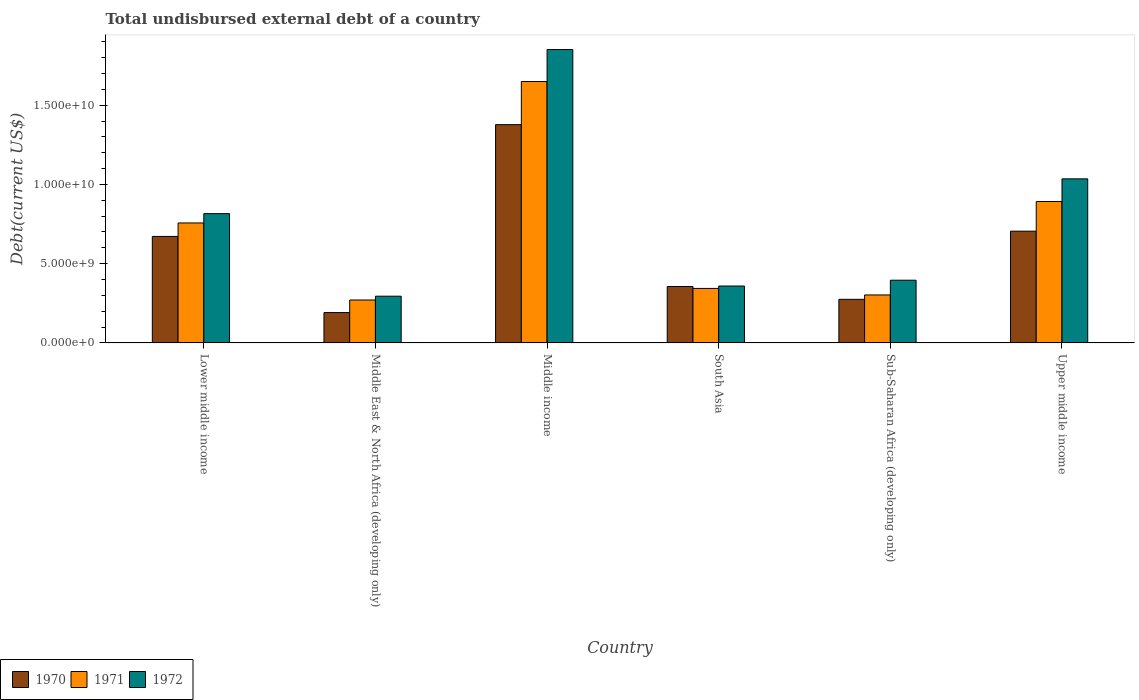How many different coloured bars are there?
Provide a short and direct response. 3. How many groups of bars are there?
Offer a very short reply. 6. Are the number of bars per tick equal to the number of legend labels?
Your answer should be very brief. Yes. Are the number of bars on each tick of the X-axis equal?
Your response must be concise. Yes. What is the label of the 2nd group of bars from the left?
Ensure brevity in your answer.  Middle East & North Africa (developing only). In how many cases, is the number of bars for a given country not equal to the number of legend labels?
Provide a short and direct response. 0. What is the total undisbursed external debt in 1972 in Middle East & North Africa (developing only)?
Offer a very short reply. 2.95e+09. Across all countries, what is the maximum total undisbursed external debt in 1970?
Give a very brief answer. 1.38e+1. Across all countries, what is the minimum total undisbursed external debt in 1972?
Provide a short and direct response. 2.95e+09. In which country was the total undisbursed external debt in 1970 minimum?
Make the answer very short. Middle East & North Africa (developing only). What is the total total undisbursed external debt in 1972 in the graph?
Offer a very short reply. 4.75e+1. What is the difference between the total undisbursed external debt in 1971 in Lower middle income and that in Middle East & North Africa (developing only)?
Your answer should be very brief. 4.86e+09. What is the difference between the total undisbursed external debt in 1970 in South Asia and the total undisbursed external debt in 1972 in Middle East & North Africa (developing only)?
Your answer should be very brief. 6.12e+08. What is the average total undisbursed external debt in 1971 per country?
Provide a short and direct response. 7.03e+09. What is the difference between the total undisbursed external debt of/in 1972 and total undisbursed external debt of/in 1970 in Middle income?
Offer a terse response. 4.74e+09. What is the ratio of the total undisbursed external debt in 1972 in South Asia to that in Sub-Saharan Africa (developing only)?
Your answer should be compact. 0.91. Is the difference between the total undisbursed external debt in 1972 in Middle East & North Africa (developing only) and Upper middle income greater than the difference between the total undisbursed external debt in 1970 in Middle East & North Africa (developing only) and Upper middle income?
Your answer should be very brief. No. What is the difference between the highest and the second highest total undisbursed external debt in 1971?
Ensure brevity in your answer.  1.35e+09. What is the difference between the highest and the lowest total undisbursed external debt in 1970?
Offer a very short reply. 1.19e+1. In how many countries, is the total undisbursed external debt in 1970 greater than the average total undisbursed external debt in 1970 taken over all countries?
Your answer should be compact. 3. Is it the case that in every country, the sum of the total undisbursed external debt in 1972 and total undisbursed external debt in 1971 is greater than the total undisbursed external debt in 1970?
Your response must be concise. Yes. How many bars are there?
Your response must be concise. 18. Are all the bars in the graph horizontal?
Offer a very short reply. No. Where does the legend appear in the graph?
Your answer should be very brief. Bottom left. What is the title of the graph?
Make the answer very short. Total undisbursed external debt of a country. Does "2012" appear as one of the legend labels in the graph?
Your response must be concise. No. What is the label or title of the Y-axis?
Your response must be concise. Debt(current US$). What is the Debt(current US$) in 1970 in Lower middle income?
Your answer should be compact. 6.72e+09. What is the Debt(current US$) in 1971 in Lower middle income?
Offer a very short reply. 7.57e+09. What is the Debt(current US$) in 1972 in Lower middle income?
Provide a short and direct response. 8.16e+09. What is the Debt(current US$) of 1970 in Middle East & North Africa (developing only)?
Your answer should be compact. 1.92e+09. What is the Debt(current US$) in 1971 in Middle East & North Africa (developing only)?
Your answer should be compact. 2.71e+09. What is the Debt(current US$) of 1972 in Middle East & North Africa (developing only)?
Offer a very short reply. 2.95e+09. What is the Debt(current US$) in 1970 in Middle income?
Your response must be concise. 1.38e+1. What is the Debt(current US$) of 1971 in Middle income?
Your answer should be compact. 1.65e+1. What is the Debt(current US$) of 1972 in Middle income?
Your answer should be compact. 1.85e+1. What is the Debt(current US$) of 1970 in South Asia?
Give a very brief answer. 3.56e+09. What is the Debt(current US$) of 1971 in South Asia?
Your response must be concise. 3.44e+09. What is the Debt(current US$) in 1972 in South Asia?
Ensure brevity in your answer.  3.59e+09. What is the Debt(current US$) in 1970 in Sub-Saharan Africa (developing only)?
Your response must be concise. 2.75e+09. What is the Debt(current US$) of 1971 in Sub-Saharan Africa (developing only)?
Offer a terse response. 3.03e+09. What is the Debt(current US$) of 1972 in Sub-Saharan Africa (developing only)?
Keep it short and to the point. 3.96e+09. What is the Debt(current US$) of 1970 in Upper middle income?
Offer a terse response. 7.05e+09. What is the Debt(current US$) in 1971 in Upper middle income?
Your answer should be compact. 8.92e+09. What is the Debt(current US$) of 1972 in Upper middle income?
Give a very brief answer. 1.04e+1. Across all countries, what is the maximum Debt(current US$) in 1970?
Your answer should be compact. 1.38e+1. Across all countries, what is the maximum Debt(current US$) of 1971?
Your answer should be compact. 1.65e+1. Across all countries, what is the maximum Debt(current US$) of 1972?
Ensure brevity in your answer.  1.85e+1. Across all countries, what is the minimum Debt(current US$) of 1970?
Offer a terse response. 1.92e+09. Across all countries, what is the minimum Debt(current US$) in 1971?
Offer a very short reply. 2.71e+09. Across all countries, what is the minimum Debt(current US$) of 1972?
Your response must be concise. 2.95e+09. What is the total Debt(current US$) of 1970 in the graph?
Your answer should be very brief. 3.58e+1. What is the total Debt(current US$) in 1971 in the graph?
Offer a terse response. 4.22e+1. What is the total Debt(current US$) of 1972 in the graph?
Provide a short and direct response. 4.75e+1. What is the difference between the Debt(current US$) of 1970 in Lower middle income and that in Middle East & North Africa (developing only)?
Give a very brief answer. 4.80e+09. What is the difference between the Debt(current US$) in 1971 in Lower middle income and that in Middle East & North Africa (developing only)?
Give a very brief answer. 4.86e+09. What is the difference between the Debt(current US$) of 1972 in Lower middle income and that in Middle East & North Africa (developing only)?
Provide a short and direct response. 5.21e+09. What is the difference between the Debt(current US$) in 1970 in Lower middle income and that in Middle income?
Keep it short and to the point. -7.05e+09. What is the difference between the Debt(current US$) of 1971 in Lower middle income and that in Middle income?
Your answer should be compact. -8.92e+09. What is the difference between the Debt(current US$) of 1972 in Lower middle income and that in Middle income?
Offer a very short reply. -1.04e+1. What is the difference between the Debt(current US$) of 1970 in Lower middle income and that in South Asia?
Your answer should be very brief. 3.16e+09. What is the difference between the Debt(current US$) of 1971 in Lower middle income and that in South Asia?
Your response must be concise. 4.13e+09. What is the difference between the Debt(current US$) of 1972 in Lower middle income and that in South Asia?
Your response must be concise. 4.57e+09. What is the difference between the Debt(current US$) in 1970 in Lower middle income and that in Sub-Saharan Africa (developing only)?
Provide a short and direct response. 3.97e+09. What is the difference between the Debt(current US$) in 1971 in Lower middle income and that in Sub-Saharan Africa (developing only)?
Offer a very short reply. 4.54e+09. What is the difference between the Debt(current US$) in 1972 in Lower middle income and that in Sub-Saharan Africa (developing only)?
Make the answer very short. 4.20e+09. What is the difference between the Debt(current US$) in 1970 in Lower middle income and that in Upper middle income?
Ensure brevity in your answer.  -3.32e+08. What is the difference between the Debt(current US$) of 1971 in Lower middle income and that in Upper middle income?
Keep it short and to the point. -1.35e+09. What is the difference between the Debt(current US$) of 1972 in Lower middle income and that in Upper middle income?
Make the answer very short. -2.20e+09. What is the difference between the Debt(current US$) of 1970 in Middle East & North Africa (developing only) and that in Middle income?
Make the answer very short. -1.19e+1. What is the difference between the Debt(current US$) in 1971 in Middle East & North Africa (developing only) and that in Middle income?
Offer a terse response. -1.38e+1. What is the difference between the Debt(current US$) in 1972 in Middle East & North Africa (developing only) and that in Middle income?
Keep it short and to the point. -1.56e+1. What is the difference between the Debt(current US$) in 1970 in Middle East & North Africa (developing only) and that in South Asia?
Make the answer very short. -1.64e+09. What is the difference between the Debt(current US$) in 1971 in Middle East & North Africa (developing only) and that in South Asia?
Your answer should be compact. -7.30e+08. What is the difference between the Debt(current US$) in 1972 in Middle East & North Africa (developing only) and that in South Asia?
Keep it short and to the point. -6.42e+08. What is the difference between the Debt(current US$) of 1970 in Middle East & North Africa (developing only) and that in Sub-Saharan Africa (developing only)?
Make the answer very short. -8.36e+08. What is the difference between the Debt(current US$) of 1971 in Middle East & North Africa (developing only) and that in Sub-Saharan Africa (developing only)?
Your answer should be compact. -3.18e+08. What is the difference between the Debt(current US$) of 1972 in Middle East & North Africa (developing only) and that in Sub-Saharan Africa (developing only)?
Your answer should be compact. -1.01e+09. What is the difference between the Debt(current US$) of 1970 in Middle East & North Africa (developing only) and that in Upper middle income?
Keep it short and to the point. -5.14e+09. What is the difference between the Debt(current US$) of 1971 in Middle East & North Africa (developing only) and that in Upper middle income?
Your answer should be very brief. -6.21e+09. What is the difference between the Debt(current US$) in 1972 in Middle East & North Africa (developing only) and that in Upper middle income?
Offer a very short reply. -7.40e+09. What is the difference between the Debt(current US$) of 1970 in Middle income and that in South Asia?
Make the answer very short. 1.02e+1. What is the difference between the Debt(current US$) in 1971 in Middle income and that in South Asia?
Give a very brief answer. 1.31e+1. What is the difference between the Debt(current US$) in 1972 in Middle income and that in South Asia?
Offer a terse response. 1.49e+1. What is the difference between the Debt(current US$) in 1970 in Middle income and that in Sub-Saharan Africa (developing only)?
Offer a terse response. 1.10e+1. What is the difference between the Debt(current US$) of 1971 in Middle income and that in Sub-Saharan Africa (developing only)?
Give a very brief answer. 1.35e+1. What is the difference between the Debt(current US$) of 1972 in Middle income and that in Sub-Saharan Africa (developing only)?
Make the answer very short. 1.46e+1. What is the difference between the Debt(current US$) in 1970 in Middle income and that in Upper middle income?
Offer a very short reply. 6.72e+09. What is the difference between the Debt(current US$) in 1971 in Middle income and that in Upper middle income?
Provide a short and direct response. 7.57e+09. What is the difference between the Debt(current US$) of 1972 in Middle income and that in Upper middle income?
Give a very brief answer. 8.16e+09. What is the difference between the Debt(current US$) in 1970 in South Asia and that in Sub-Saharan Africa (developing only)?
Your response must be concise. 8.09e+08. What is the difference between the Debt(current US$) in 1971 in South Asia and that in Sub-Saharan Africa (developing only)?
Make the answer very short. 4.11e+08. What is the difference between the Debt(current US$) of 1972 in South Asia and that in Sub-Saharan Africa (developing only)?
Ensure brevity in your answer.  -3.67e+08. What is the difference between the Debt(current US$) of 1970 in South Asia and that in Upper middle income?
Ensure brevity in your answer.  -3.49e+09. What is the difference between the Debt(current US$) of 1971 in South Asia and that in Upper middle income?
Keep it short and to the point. -5.48e+09. What is the difference between the Debt(current US$) in 1972 in South Asia and that in Upper middle income?
Offer a very short reply. -6.76e+09. What is the difference between the Debt(current US$) in 1970 in Sub-Saharan Africa (developing only) and that in Upper middle income?
Your answer should be compact. -4.30e+09. What is the difference between the Debt(current US$) of 1971 in Sub-Saharan Africa (developing only) and that in Upper middle income?
Your response must be concise. -5.89e+09. What is the difference between the Debt(current US$) in 1972 in Sub-Saharan Africa (developing only) and that in Upper middle income?
Provide a succinct answer. -6.39e+09. What is the difference between the Debt(current US$) in 1970 in Lower middle income and the Debt(current US$) in 1971 in Middle East & North Africa (developing only)?
Ensure brevity in your answer.  4.01e+09. What is the difference between the Debt(current US$) of 1970 in Lower middle income and the Debt(current US$) of 1972 in Middle East & North Africa (developing only)?
Keep it short and to the point. 3.77e+09. What is the difference between the Debt(current US$) in 1971 in Lower middle income and the Debt(current US$) in 1972 in Middle East & North Africa (developing only)?
Your response must be concise. 4.62e+09. What is the difference between the Debt(current US$) of 1970 in Lower middle income and the Debt(current US$) of 1971 in Middle income?
Provide a succinct answer. -9.77e+09. What is the difference between the Debt(current US$) of 1970 in Lower middle income and the Debt(current US$) of 1972 in Middle income?
Ensure brevity in your answer.  -1.18e+1. What is the difference between the Debt(current US$) in 1971 in Lower middle income and the Debt(current US$) in 1972 in Middle income?
Your response must be concise. -1.09e+1. What is the difference between the Debt(current US$) in 1970 in Lower middle income and the Debt(current US$) in 1971 in South Asia?
Ensure brevity in your answer.  3.28e+09. What is the difference between the Debt(current US$) in 1970 in Lower middle income and the Debt(current US$) in 1972 in South Asia?
Your answer should be very brief. 3.13e+09. What is the difference between the Debt(current US$) of 1971 in Lower middle income and the Debt(current US$) of 1972 in South Asia?
Provide a short and direct response. 3.98e+09. What is the difference between the Debt(current US$) in 1970 in Lower middle income and the Debt(current US$) in 1971 in Sub-Saharan Africa (developing only)?
Your answer should be very brief. 3.69e+09. What is the difference between the Debt(current US$) in 1970 in Lower middle income and the Debt(current US$) in 1972 in Sub-Saharan Africa (developing only)?
Ensure brevity in your answer.  2.76e+09. What is the difference between the Debt(current US$) of 1971 in Lower middle income and the Debt(current US$) of 1972 in Sub-Saharan Africa (developing only)?
Provide a short and direct response. 3.61e+09. What is the difference between the Debt(current US$) of 1970 in Lower middle income and the Debt(current US$) of 1971 in Upper middle income?
Offer a terse response. -2.20e+09. What is the difference between the Debt(current US$) in 1970 in Lower middle income and the Debt(current US$) in 1972 in Upper middle income?
Your answer should be very brief. -3.63e+09. What is the difference between the Debt(current US$) in 1971 in Lower middle income and the Debt(current US$) in 1972 in Upper middle income?
Provide a short and direct response. -2.78e+09. What is the difference between the Debt(current US$) in 1970 in Middle East & North Africa (developing only) and the Debt(current US$) in 1971 in Middle income?
Keep it short and to the point. -1.46e+1. What is the difference between the Debt(current US$) in 1970 in Middle East & North Africa (developing only) and the Debt(current US$) in 1972 in Middle income?
Ensure brevity in your answer.  -1.66e+1. What is the difference between the Debt(current US$) in 1971 in Middle East & North Africa (developing only) and the Debt(current US$) in 1972 in Middle income?
Provide a succinct answer. -1.58e+1. What is the difference between the Debt(current US$) of 1970 in Middle East & North Africa (developing only) and the Debt(current US$) of 1971 in South Asia?
Provide a succinct answer. -1.52e+09. What is the difference between the Debt(current US$) in 1970 in Middle East & North Africa (developing only) and the Debt(current US$) in 1972 in South Asia?
Your response must be concise. -1.67e+09. What is the difference between the Debt(current US$) of 1971 in Middle East & North Africa (developing only) and the Debt(current US$) of 1972 in South Asia?
Offer a terse response. -8.81e+08. What is the difference between the Debt(current US$) of 1970 in Middle East & North Africa (developing only) and the Debt(current US$) of 1971 in Sub-Saharan Africa (developing only)?
Make the answer very short. -1.11e+09. What is the difference between the Debt(current US$) of 1970 in Middle East & North Africa (developing only) and the Debt(current US$) of 1972 in Sub-Saharan Africa (developing only)?
Ensure brevity in your answer.  -2.04e+09. What is the difference between the Debt(current US$) in 1971 in Middle East & North Africa (developing only) and the Debt(current US$) in 1972 in Sub-Saharan Africa (developing only)?
Offer a terse response. -1.25e+09. What is the difference between the Debt(current US$) of 1970 in Middle East & North Africa (developing only) and the Debt(current US$) of 1971 in Upper middle income?
Make the answer very short. -7.01e+09. What is the difference between the Debt(current US$) in 1970 in Middle East & North Africa (developing only) and the Debt(current US$) in 1972 in Upper middle income?
Give a very brief answer. -8.44e+09. What is the difference between the Debt(current US$) of 1971 in Middle East & North Africa (developing only) and the Debt(current US$) of 1972 in Upper middle income?
Your response must be concise. -7.64e+09. What is the difference between the Debt(current US$) of 1970 in Middle income and the Debt(current US$) of 1971 in South Asia?
Your response must be concise. 1.03e+1. What is the difference between the Debt(current US$) of 1970 in Middle income and the Debt(current US$) of 1972 in South Asia?
Your answer should be very brief. 1.02e+1. What is the difference between the Debt(current US$) in 1971 in Middle income and the Debt(current US$) in 1972 in South Asia?
Provide a short and direct response. 1.29e+1. What is the difference between the Debt(current US$) of 1970 in Middle income and the Debt(current US$) of 1971 in Sub-Saharan Africa (developing only)?
Your response must be concise. 1.07e+1. What is the difference between the Debt(current US$) of 1970 in Middle income and the Debt(current US$) of 1972 in Sub-Saharan Africa (developing only)?
Provide a succinct answer. 9.81e+09. What is the difference between the Debt(current US$) in 1971 in Middle income and the Debt(current US$) in 1972 in Sub-Saharan Africa (developing only)?
Your answer should be very brief. 1.25e+1. What is the difference between the Debt(current US$) in 1970 in Middle income and the Debt(current US$) in 1971 in Upper middle income?
Make the answer very short. 4.85e+09. What is the difference between the Debt(current US$) in 1970 in Middle income and the Debt(current US$) in 1972 in Upper middle income?
Your answer should be compact. 3.42e+09. What is the difference between the Debt(current US$) in 1971 in Middle income and the Debt(current US$) in 1972 in Upper middle income?
Your answer should be compact. 6.14e+09. What is the difference between the Debt(current US$) in 1970 in South Asia and the Debt(current US$) in 1971 in Sub-Saharan Africa (developing only)?
Your answer should be compact. 5.33e+08. What is the difference between the Debt(current US$) in 1970 in South Asia and the Debt(current US$) in 1972 in Sub-Saharan Africa (developing only)?
Your response must be concise. -3.97e+08. What is the difference between the Debt(current US$) in 1971 in South Asia and the Debt(current US$) in 1972 in Sub-Saharan Africa (developing only)?
Offer a very short reply. -5.18e+08. What is the difference between the Debt(current US$) in 1970 in South Asia and the Debt(current US$) in 1971 in Upper middle income?
Make the answer very short. -5.36e+09. What is the difference between the Debt(current US$) of 1970 in South Asia and the Debt(current US$) of 1972 in Upper middle income?
Your answer should be compact. -6.79e+09. What is the difference between the Debt(current US$) in 1971 in South Asia and the Debt(current US$) in 1972 in Upper middle income?
Make the answer very short. -6.91e+09. What is the difference between the Debt(current US$) in 1970 in Sub-Saharan Africa (developing only) and the Debt(current US$) in 1971 in Upper middle income?
Ensure brevity in your answer.  -6.17e+09. What is the difference between the Debt(current US$) of 1970 in Sub-Saharan Africa (developing only) and the Debt(current US$) of 1972 in Upper middle income?
Your answer should be compact. -7.60e+09. What is the difference between the Debt(current US$) in 1971 in Sub-Saharan Africa (developing only) and the Debt(current US$) in 1972 in Upper middle income?
Offer a terse response. -7.32e+09. What is the average Debt(current US$) in 1970 per country?
Your answer should be very brief. 5.96e+09. What is the average Debt(current US$) of 1971 per country?
Keep it short and to the point. 7.03e+09. What is the average Debt(current US$) of 1972 per country?
Provide a succinct answer. 7.92e+09. What is the difference between the Debt(current US$) in 1970 and Debt(current US$) in 1971 in Lower middle income?
Your response must be concise. -8.50e+08. What is the difference between the Debt(current US$) of 1970 and Debt(current US$) of 1972 in Lower middle income?
Your answer should be very brief. -1.44e+09. What is the difference between the Debt(current US$) in 1971 and Debt(current US$) in 1972 in Lower middle income?
Your response must be concise. -5.87e+08. What is the difference between the Debt(current US$) in 1970 and Debt(current US$) in 1971 in Middle East & North Africa (developing only)?
Give a very brief answer. -7.94e+08. What is the difference between the Debt(current US$) of 1970 and Debt(current US$) of 1972 in Middle East & North Africa (developing only)?
Ensure brevity in your answer.  -1.03e+09. What is the difference between the Debt(current US$) of 1971 and Debt(current US$) of 1972 in Middle East & North Africa (developing only)?
Give a very brief answer. -2.39e+08. What is the difference between the Debt(current US$) in 1970 and Debt(current US$) in 1971 in Middle income?
Give a very brief answer. -2.72e+09. What is the difference between the Debt(current US$) in 1970 and Debt(current US$) in 1972 in Middle income?
Your response must be concise. -4.74e+09. What is the difference between the Debt(current US$) in 1971 and Debt(current US$) in 1972 in Middle income?
Provide a succinct answer. -2.02e+09. What is the difference between the Debt(current US$) of 1970 and Debt(current US$) of 1971 in South Asia?
Provide a short and direct response. 1.21e+08. What is the difference between the Debt(current US$) in 1970 and Debt(current US$) in 1972 in South Asia?
Your answer should be very brief. -3.02e+07. What is the difference between the Debt(current US$) of 1971 and Debt(current US$) of 1972 in South Asia?
Give a very brief answer. -1.51e+08. What is the difference between the Debt(current US$) in 1970 and Debt(current US$) in 1971 in Sub-Saharan Africa (developing only)?
Your answer should be very brief. -2.76e+08. What is the difference between the Debt(current US$) of 1970 and Debt(current US$) of 1972 in Sub-Saharan Africa (developing only)?
Your response must be concise. -1.21e+09. What is the difference between the Debt(current US$) in 1971 and Debt(current US$) in 1972 in Sub-Saharan Africa (developing only)?
Ensure brevity in your answer.  -9.29e+08. What is the difference between the Debt(current US$) in 1970 and Debt(current US$) in 1971 in Upper middle income?
Offer a terse response. -1.87e+09. What is the difference between the Debt(current US$) in 1970 and Debt(current US$) in 1972 in Upper middle income?
Your response must be concise. -3.30e+09. What is the difference between the Debt(current US$) of 1971 and Debt(current US$) of 1972 in Upper middle income?
Your response must be concise. -1.43e+09. What is the ratio of the Debt(current US$) of 1970 in Lower middle income to that in Middle East & North Africa (developing only)?
Offer a very short reply. 3.51. What is the ratio of the Debt(current US$) of 1971 in Lower middle income to that in Middle East & North Africa (developing only)?
Your answer should be compact. 2.79. What is the ratio of the Debt(current US$) in 1972 in Lower middle income to that in Middle East & North Africa (developing only)?
Offer a terse response. 2.77. What is the ratio of the Debt(current US$) of 1970 in Lower middle income to that in Middle income?
Your response must be concise. 0.49. What is the ratio of the Debt(current US$) in 1971 in Lower middle income to that in Middle income?
Offer a terse response. 0.46. What is the ratio of the Debt(current US$) in 1972 in Lower middle income to that in Middle income?
Provide a succinct answer. 0.44. What is the ratio of the Debt(current US$) of 1970 in Lower middle income to that in South Asia?
Provide a short and direct response. 1.89. What is the ratio of the Debt(current US$) of 1971 in Lower middle income to that in South Asia?
Your answer should be compact. 2.2. What is the ratio of the Debt(current US$) of 1972 in Lower middle income to that in South Asia?
Provide a short and direct response. 2.27. What is the ratio of the Debt(current US$) of 1970 in Lower middle income to that in Sub-Saharan Africa (developing only)?
Your response must be concise. 2.44. What is the ratio of the Debt(current US$) in 1971 in Lower middle income to that in Sub-Saharan Africa (developing only)?
Your answer should be very brief. 2.5. What is the ratio of the Debt(current US$) in 1972 in Lower middle income to that in Sub-Saharan Africa (developing only)?
Give a very brief answer. 2.06. What is the ratio of the Debt(current US$) of 1970 in Lower middle income to that in Upper middle income?
Offer a terse response. 0.95. What is the ratio of the Debt(current US$) of 1971 in Lower middle income to that in Upper middle income?
Ensure brevity in your answer.  0.85. What is the ratio of the Debt(current US$) in 1972 in Lower middle income to that in Upper middle income?
Give a very brief answer. 0.79. What is the ratio of the Debt(current US$) of 1970 in Middle East & North Africa (developing only) to that in Middle income?
Provide a short and direct response. 0.14. What is the ratio of the Debt(current US$) in 1971 in Middle East & North Africa (developing only) to that in Middle income?
Provide a succinct answer. 0.16. What is the ratio of the Debt(current US$) of 1972 in Middle East & North Africa (developing only) to that in Middle income?
Offer a very short reply. 0.16. What is the ratio of the Debt(current US$) in 1970 in Middle East & North Africa (developing only) to that in South Asia?
Provide a succinct answer. 0.54. What is the ratio of the Debt(current US$) in 1971 in Middle East & North Africa (developing only) to that in South Asia?
Make the answer very short. 0.79. What is the ratio of the Debt(current US$) in 1972 in Middle East & North Africa (developing only) to that in South Asia?
Give a very brief answer. 0.82. What is the ratio of the Debt(current US$) in 1970 in Middle East & North Africa (developing only) to that in Sub-Saharan Africa (developing only)?
Offer a terse response. 0.7. What is the ratio of the Debt(current US$) in 1971 in Middle East & North Africa (developing only) to that in Sub-Saharan Africa (developing only)?
Your response must be concise. 0.89. What is the ratio of the Debt(current US$) of 1972 in Middle East & North Africa (developing only) to that in Sub-Saharan Africa (developing only)?
Offer a terse response. 0.75. What is the ratio of the Debt(current US$) of 1970 in Middle East & North Africa (developing only) to that in Upper middle income?
Offer a very short reply. 0.27. What is the ratio of the Debt(current US$) of 1971 in Middle East & North Africa (developing only) to that in Upper middle income?
Your answer should be very brief. 0.3. What is the ratio of the Debt(current US$) in 1972 in Middle East & North Africa (developing only) to that in Upper middle income?
Make the answer very short. 0.28. What is the ratio of the Debt(current US$) of 1970 in Middle income to that in South Asia?
Provide a succinct answer. 3.87. What is the ratio of the Debt(current US$) in 1971 in Middle income to that in South Asia?
Your response must be concise. 4.8. What is the ratio of the Debt(current US$) in 1972 in Middle income to that in South Asia?
Keep it short and to the point. 5.15. What is the ratio of the Debt(current US$) in 1970 in Middle income to that in Sub-Saharan Africa (developing only)?
Offer a very short reply. 5. What is the ratio of the Debt(current US$) of 1971 in Middle income to that in Sub-Saharan Africa (developing only)?
Your answer should be compact. 5.45. What is the ratio of the Debt(current US$) of 1972 in Middle income to that in Sub-Saharan Africa (developing only)?
Your answer should be very brief. 4.68. What is the ratio of the Debt(current US$) of 1970 in Middle income to that in Upper middle income?
Provide a short and direct response. 1.95. What is the ratio of the Debt(current US$) in 1971 in Middle income to that in Upper middle income?
Keep it short and to the point. 1.85. What is the ratio of the Debt(current US$) of 1972 in Middle income to that in Upper middle income?
Make the answer very short. 1.79. What is the ratio of the Debt(current US$) in 1970 in South Asia to that in Sub-Saharan Africa (developing only)?
Give a very brief answer. 1.29. What is the ratio of the Debt(current US$) of 1971 in South Asia to that in Sub-Saharan Africa (developing only)?
Make the answer very short. 1.14. What is the ratio of the Debt(current US$) of 1972 in South Asia to that in Sub-Saharan Africa (developing only)?
Provide a succinct answer. 0.91. What is the ratio of the Debt(current US$) of 1970 in South Asia to that in Upper middle income?
Provide a succinct answer. 0.5. What is the ratio of the Debt(current US$) of 1971 in South Asia to that in Upper middle income?
Offer a terse response. 0.39. What is the ratio of the Debt(current US$) of 1972 in South Asia to that in Upper middle income?
Make the answer very short. 0.35. What is the ratio of the Debt(current US$) of 1970 in Sub-Saharan Africa (developing only) to that in Upper middle income?
Provide a succinct answer. 0.39. What is the ratio of the Debt(current US$) of 1971 in Sub-Saharan Africa (developing only) to that in Upper middle income?
Your answer should be very brief. 0.34. What is the ratio of the Debt(current US$) of 1972 in Sub-Saharan Africa (developing only) to that in Upper middle income?
Offer a very short reply. 0.38. What is the difference between the highest and the second highest Debt(current US$) of 1970?
Provide a succinct answer. 6.72e+09. What is the difference between the highest and the second highest Debt(current US$) in 1971?
Offer a very short reply. 7.57e+09. What is the difference between the highest and the second highest Debt(current US$) of 1972?
Your answer should be very brief. 8.16e+09. What is the difference between the highest and the lowest Debt(current US$) in 1970?
Your answer should be very brief. 1.19e+1. What is the difference between the highest and the lowest Debt(current US$) of 1971?
Provide a succinct answer. 1.38e+1. What is the difference between the highest and the lowest Debt(current US$) in 1972?
Provide a short and direct response. 1.56e+1. 